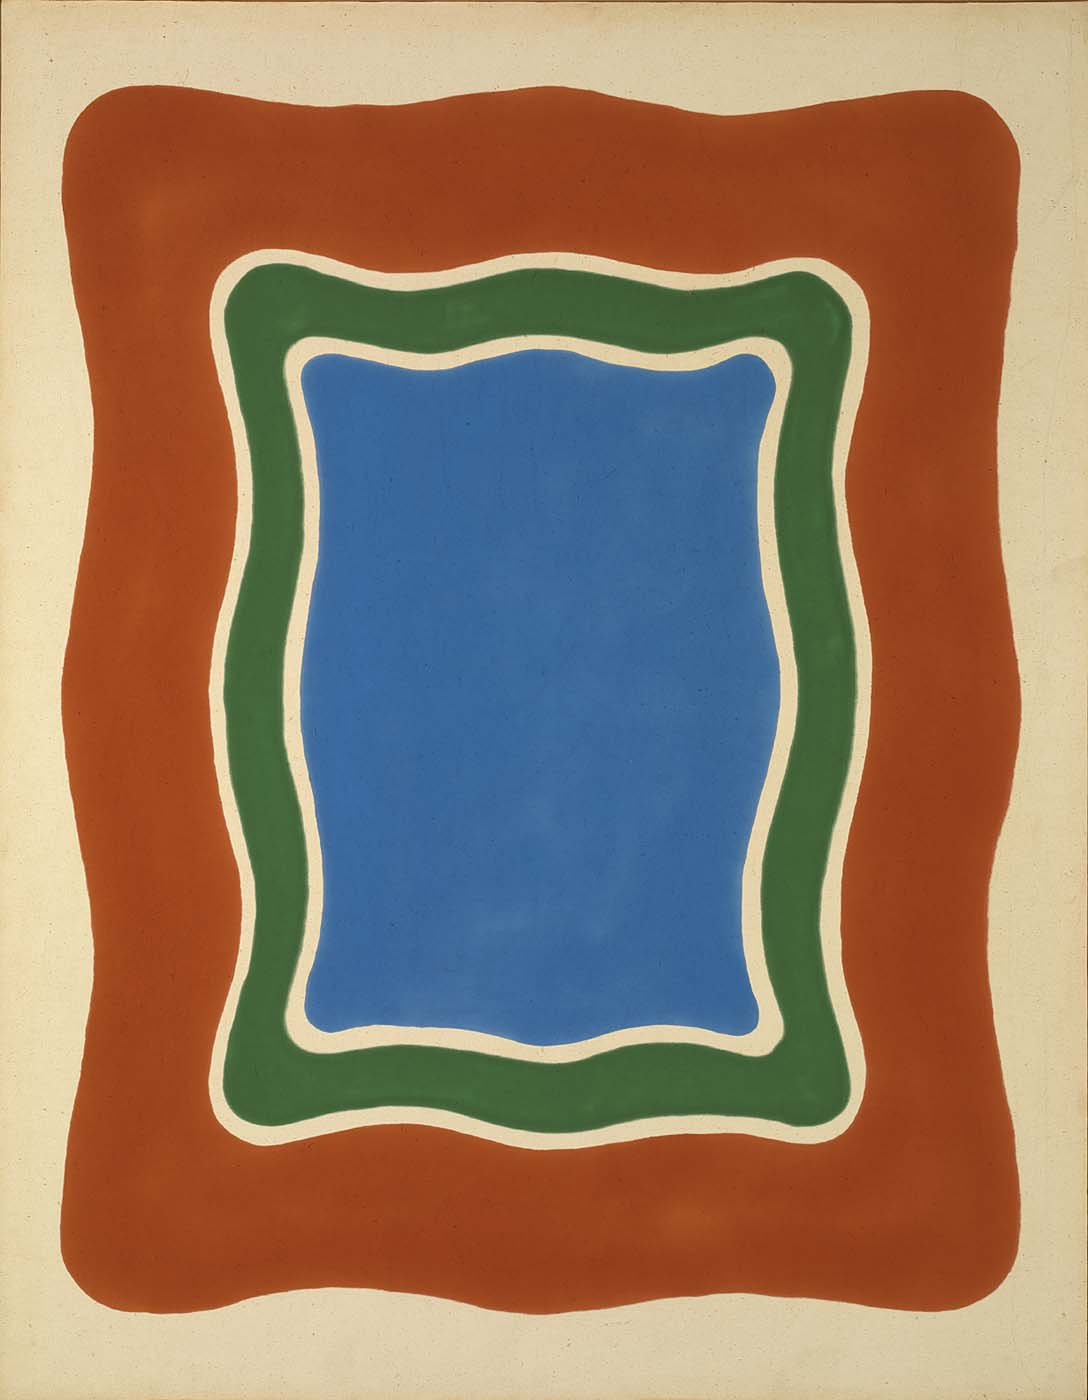What emotions do you think the artist intended to evoke with this piece? The artist's use of bold and vibrant colors likely aims to evoke feelings of intensity and energy. The juxtaposition of the deep blue rectangle with the dynamic green and red borders suggests both calmness and excitement, inviting an introspective yet stimulating experience. The organic, flowing lines may evoke a sense of fluidity and natural progression, hinting at themes of growth, harmony, and transformation. 